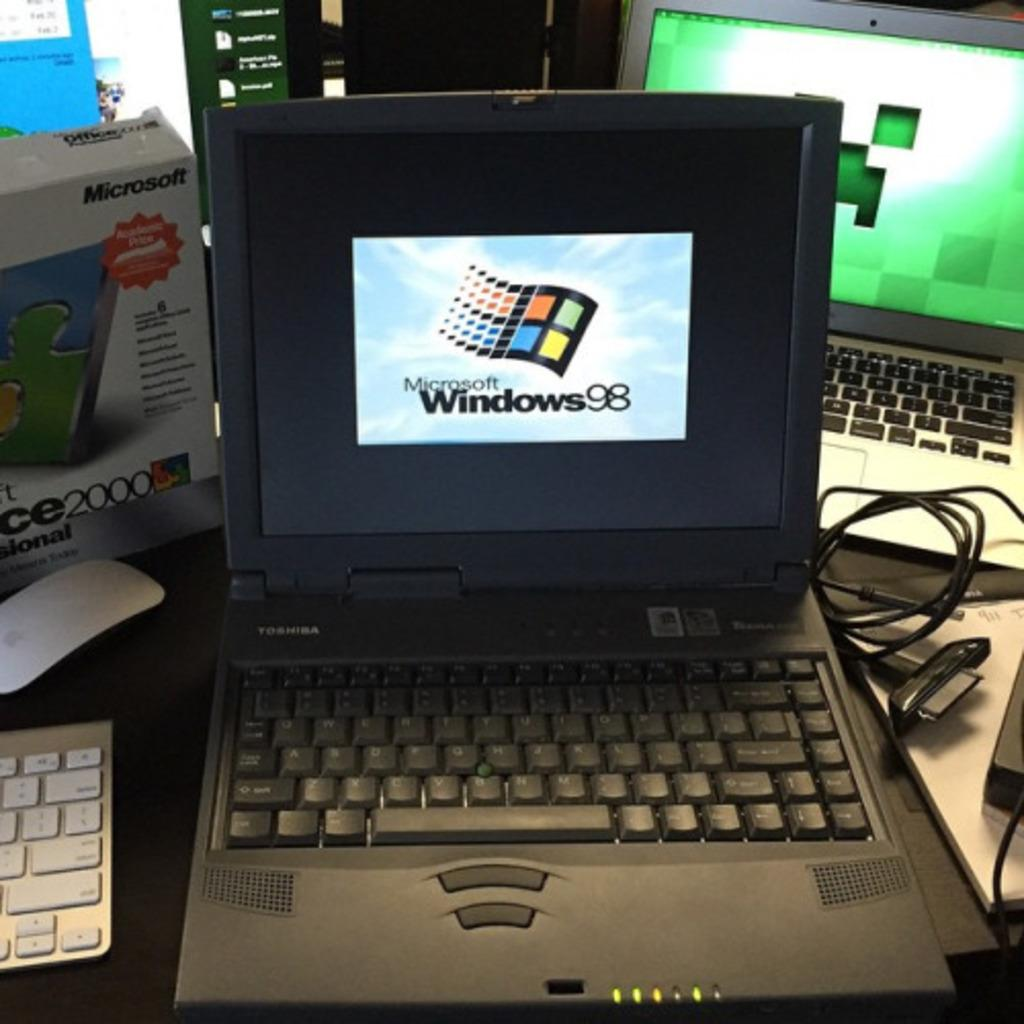<image>
Offer a succinct explanation of the picture presented. A computer screen has the Windows 98 logo on it. 